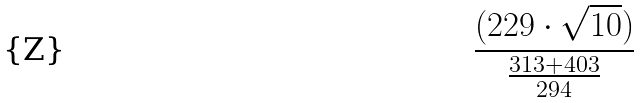Convert formula to latex. <formula><loc_0><loc_0><loc_500><loc_500>\frac { ( 2 2 9 \cdot \sqrt { 1 0 } ) } { \frac { 3 1 3 + 4 0 3 } { 2 9 4 } }</formula> 